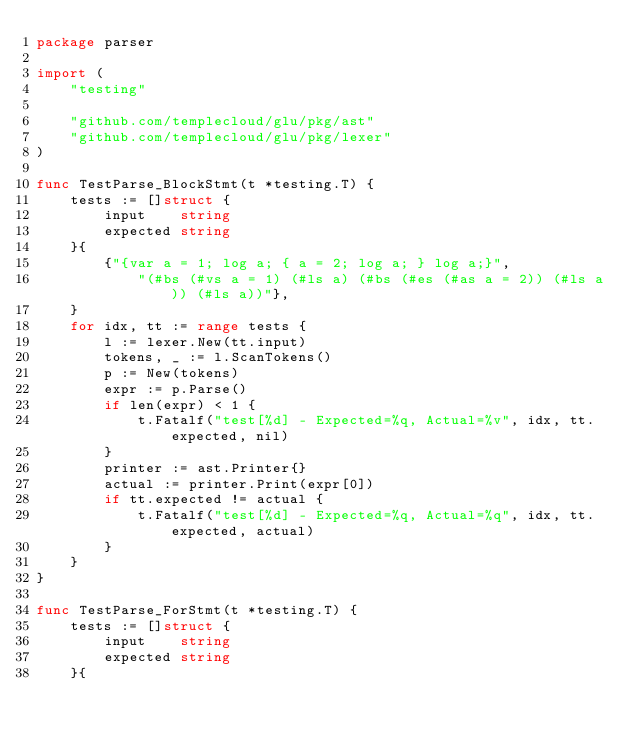Convert code to text. <code><loc_0><loc_0><loc_500><loc_500><_Go_>package parser

import (
	"testing"

	"github.com/templecloud/glu/pkg/ast"
	"github.com/templecloud/glu/pkg/lexer"
)

func TestParse_BlockStmt(t *testing.T) {
	tests := []struct {
		input    string
		expected string
	}{
		{"{var a = 1; log a; { a = 2; log a; } log a;}",
			"(#bs (#vs a = 1) (#ls a) (#bs (#es (#as a = 2)) (#ls a)) (#ls a))"},
	}
	for idx, tt := range tests {
		l := lexer.New(tt.input)
		tokens, _ := l.ScanTokens()
		p := New(tokens)
		expr := p.Parse()
		if len(expr) < 1 {
			t.Fatalf("test[%d] - Expected=%q, Actual=%v", idx, tt.expected, nil)
		}
		printer := ast.Printer{}
		actual := printer.Print(expr[0])
		if tt.expected != actual {
			t.Fatalf("test[%d] - Expected=%q, Actual=%q", idx, tt.expected, actual)
		}
	}
}

func TestParse_ForStmt(t *testing.T) {
	tests := []struct {
		input    string
		expected string
	}{</code> 